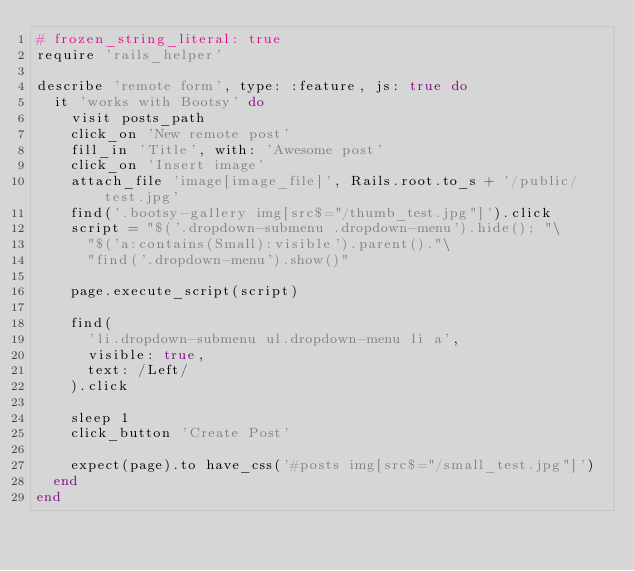Convert code to text. <code><loc_0><loc_0><loc_500><loc_500><_Ruby_># frozen_string_literal: true
require 'rails_helper'

describe 'remote form', type: :feature, js: true do
  it 'works with Bootsy' do
    visit posts_path
    click_on 'New remote post'
    fill_in 'Title', with: 'Awesome post'
    click_on 'Insert image'
    attach_file 'image[image_file]', Rails.root.to_s + '/public/test.jpg'
    find('.bootsy-gallery img[src$="/thumb_test.jpg"]').click
    script = "$('.dropdown-submenu .dropdown-menu').hide(); "\
      "$('a:contains(Small):visible').parent()."\
      "find('.dropdown-menu').show()"

    page.execute_script(script)

    find(
      'li.dropdown-submenu ul.dropdown-menu li a',
      visible: true,
      text: /Left/
    ).click

    sleep 1
    click_button 'Create Post'

    expect(page).to have_css('#posts img[src$="/small_test.jpg"]')
  end
end
</code> 